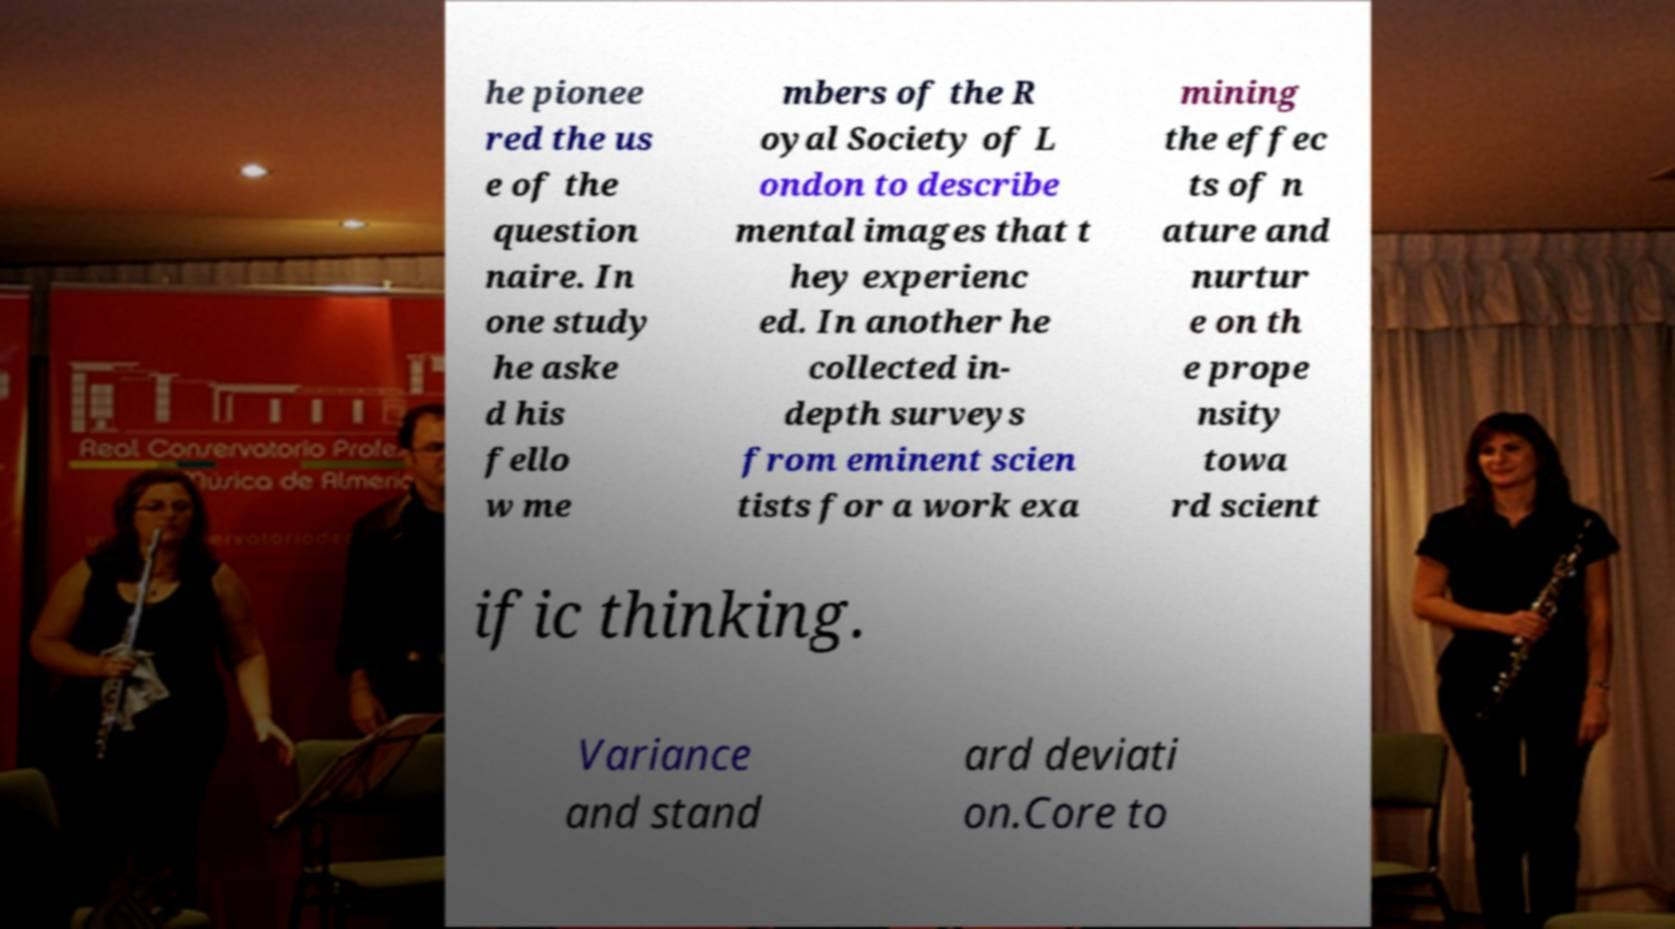What messages or text are displayed in this image? I need them in a readable, typed format. he pionee red the us e of the question naire. In one study he aske d his fello w me mbers of the R oyal Society of L ondon to describe mental images that t hey experienc ed. In another he collected in- depth surveys from eminent scien tists for a work exa mining the effec ts of n ature and nurtur e on th e prope nsity towa rd scient ific thinking. Variance and stand ard deviati on.Core to 